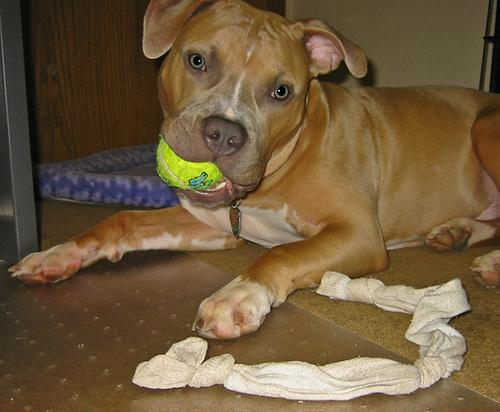Identify the breed of the dog in the image. The dog in the image appears to be an American Staffordshire Terrier, commonly known as an Amstaff. This breed is recognized for its strong, muscular build, distinguished cheek muscles, and broad head. The coat color and facial markings align with typical breed characteristics. However, breed identification based on visual cues alone can be misleading. For a definitive identification, consulting a veterinarian or a breed expert who might use a combination of physical examination, behavior analysis, and genetic testing is advisable. In addition to physical attributes, American Staffordshire Terriers are known for their loyalty and affectionate nature, making them excellent family pets when properly trained and socialized. 